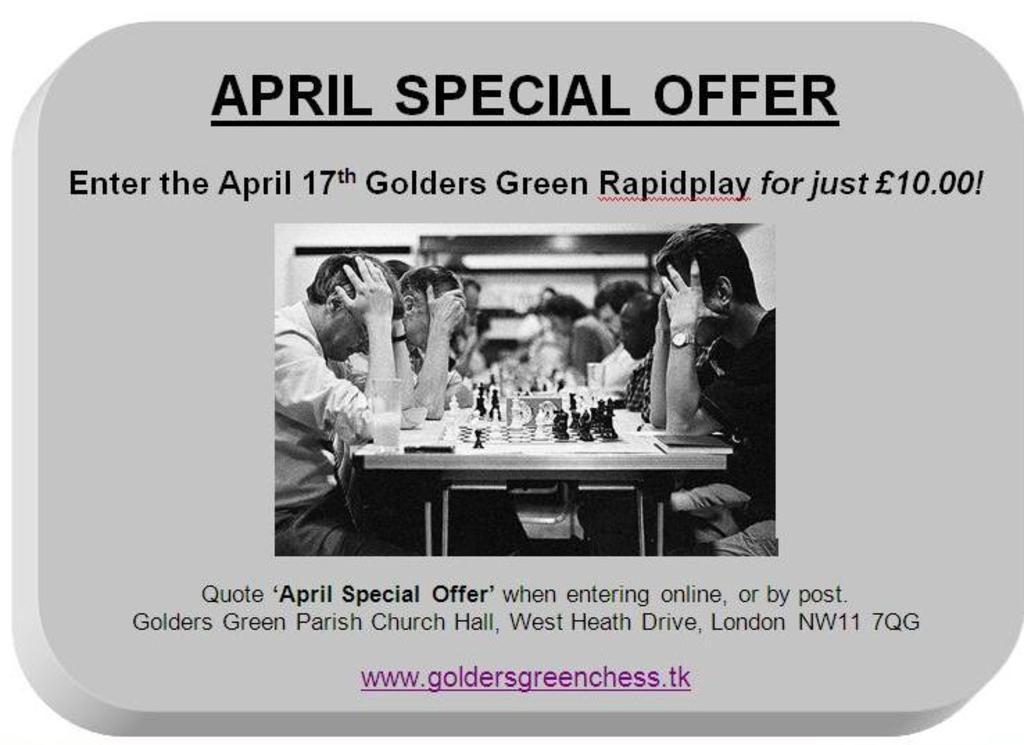What activity are the persons in the image engaged in? The persons in the image are playing chess. Where is the chess game located in the image? The chess game is in the middle of the image. What is written at the top of the image? There is text at the top of the image. What is written at the bottom of the image? There is text at the bottom of the image. What type of drum can be seen in the image? There is no drum present in the image. How low is the camera angle in the image? The camera angle is not mentioned in the provided facts, and therefore we cannot determine the camera angle from the image. 